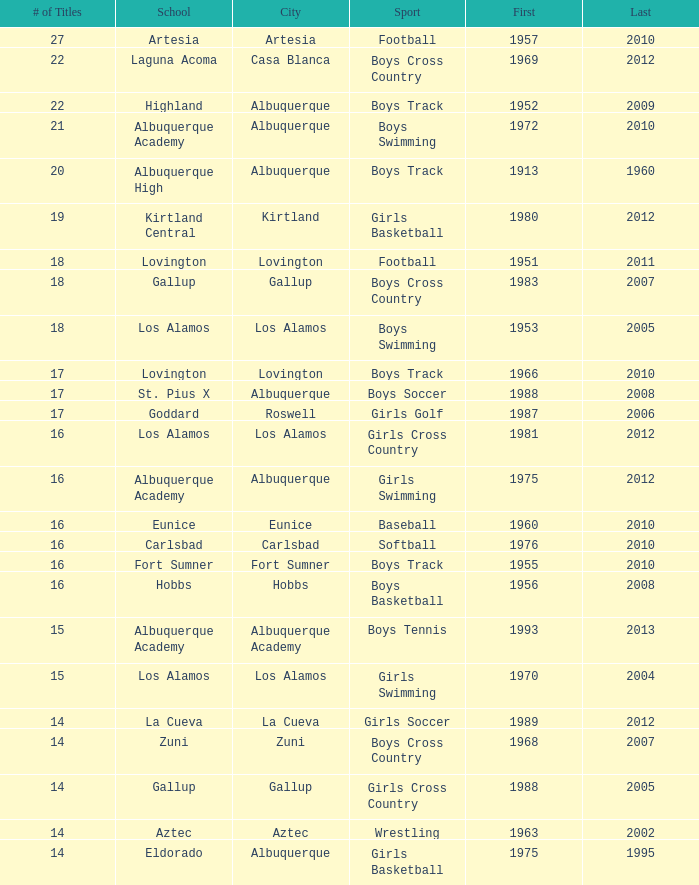What city is the School, Highland, in that ranks less than 8 and had its first title before 1980 and its last title later than 1960? Albuquerque. 